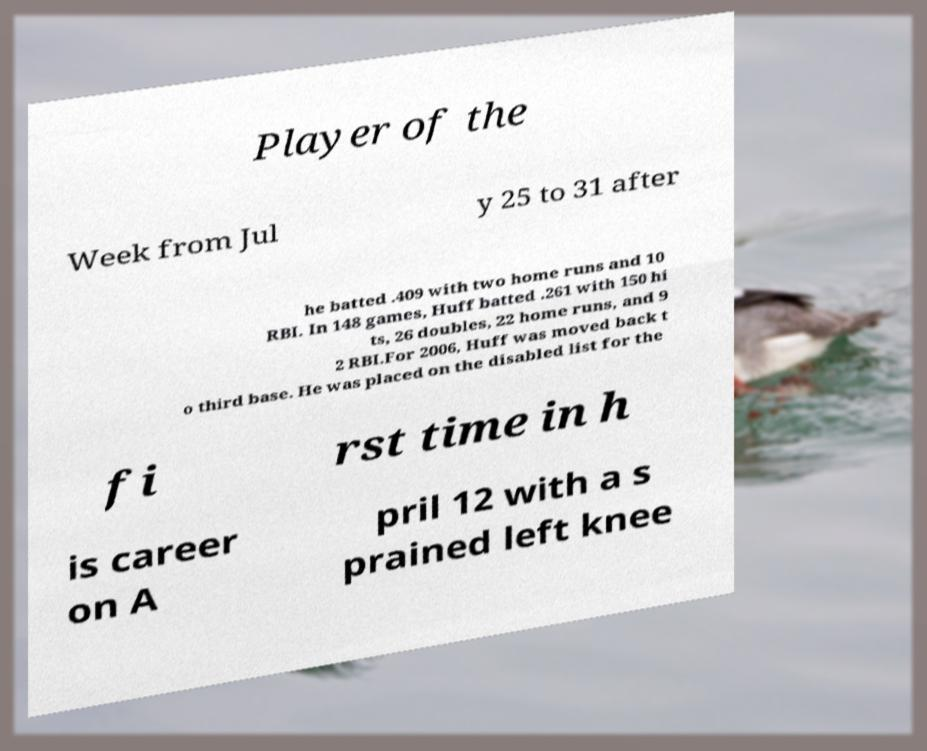Can you accurately transcribe the text from the provided image for me? Player of the Week from Jul y 25 to 31 after he batted .409 with two home runs and 10 RBI. In 148 games, Huff batted .261 with 150 hi ts, 26 doubles, 22 home runs, and 9 2 RBI.For 2006, Huff was moved back t o third base. He was placed on the disabled list for the fi rst time in h is career on A pril 12 with a s prained left knee 